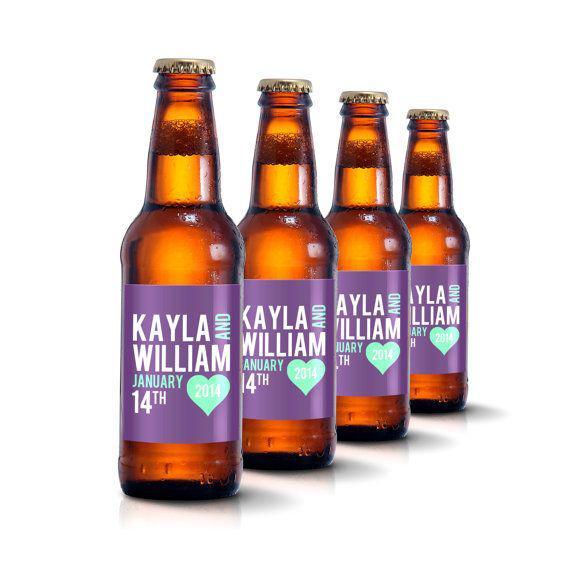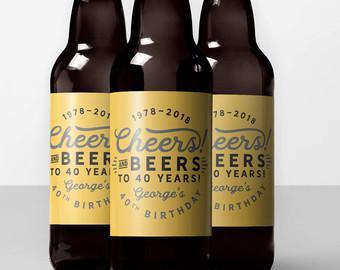The first image is the image on the left, the second image is the image on the right. For the images shown, is this caption "An image features exactly four bottles in a row." true? Answer yes or no. Yes. 